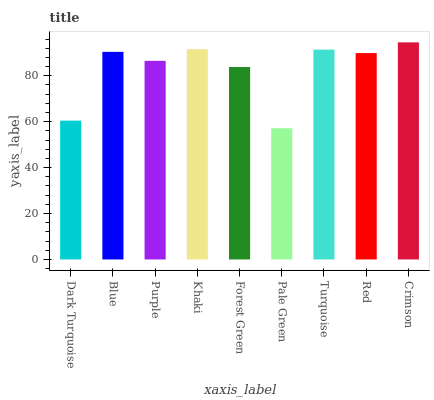Is Pale Green the minimum?
Answer yes or no. Yes. Is Crimson the maximum?
Answer yes or no. Yes. Is Blue the minimum?
Answer yes or no. No. Is Blue the maximum?
Answer yes or no. No. Is Blue greater than Dark Turquoise?
Answer yes or no. Yes. Is Dark Turquoise less than Blue?
Answer yes or no. Yes. Is Dark Turquoise greater than Blue?
Answer yes or no. No. Is Blue less than Dark Turquoise?
Answer yes or no. No. Is Red the high median?
Answer yes or no. Yes. Is Red the low median?
Answer yes or no. Yes. Is Crimson the high median?
Answer yes or no. No. Is Blue the low median?
Answer yes or no. No. 